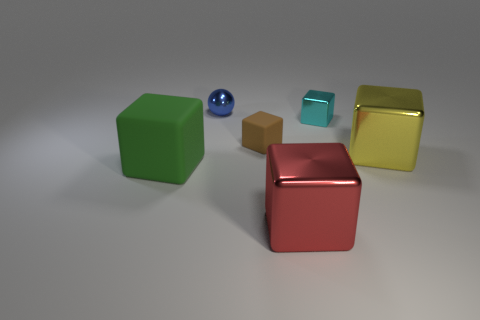Is the sphere made of the same material as the thing that is in front of the large green object?
Make the answer very short. Yes. The tiny metallic thing that is on the left side of the small metal thing that is right of the big red metal block is what shape?
Your response must be concise. Sphere. What number of tiny things are either blue shiny balls or brown matte things?
Provide a short and direct response. 2. How many other big objects have the same shape as the brown matte thing?
Ensure brevity in your answer.  3. There is a small brown object; does it have the same shape as the matte thing that is on the left side of the tiny sphere?
Offer a very short reply. Yes. How many tiny cyan metallic objects are behind the small rubber cube?
Provide a short and direct response. 1. Are there any other green objects of the same size as the green object?
Ensure brevity in your answer.  No. There is a matte thing behind the green object; does it have the same shape as the big yellow thing?
Provide a succinct answer. Yes. What is the color of the large matte object?
Make the answer very short. Green. Is there a big yellow thing?
Offer a terse response. Yes. 